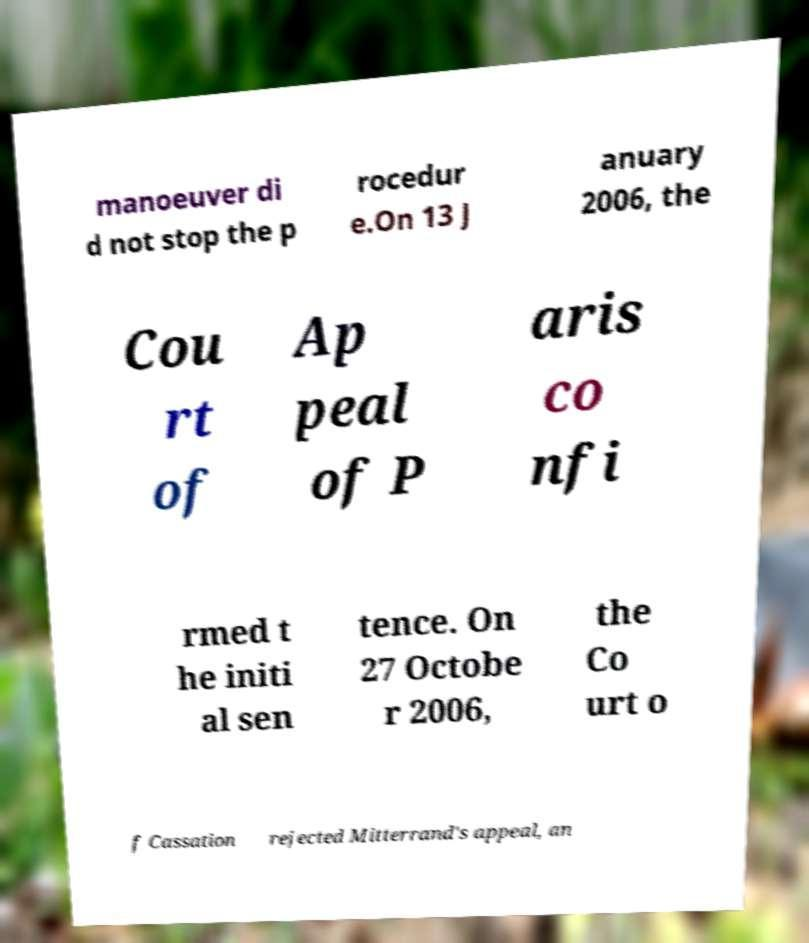I need the written content from this picture converted into text. Can you do that? manoeuver di d not stop the p rocedur e.On 13 J anuary 2006, the Cou rt of Ap peal of P aris co nfi rmed t he initi al sen tence. On 27 Octobe r 2006, the Co urt o f Cassation rejected Mitterrand's appeal, an 